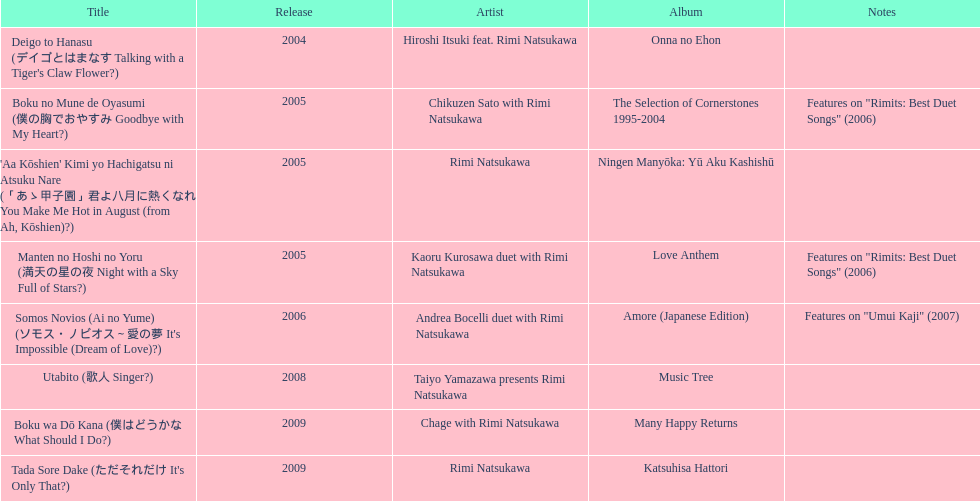What is the album that came out right before the one with "boku wa do kana" on it? Music Tree. 